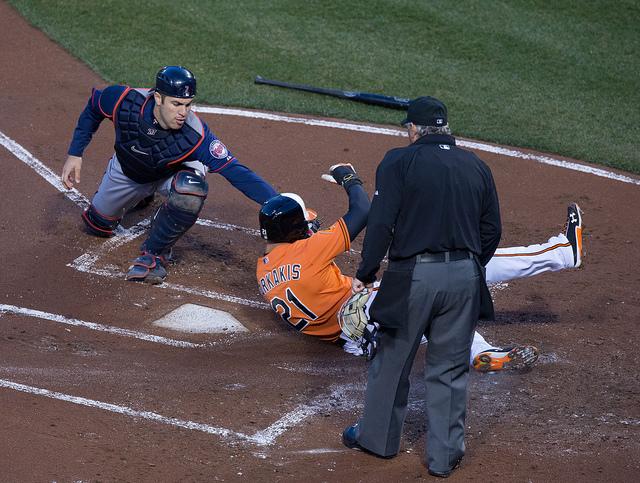What is the man doing?
Keep it brief. Sliding. What hand is the catcher tagging the runner with?
Concise answer only. Left. What no is on the man's orange t shirt?
Answer briefly. 21. What sport are they playing?
Answer briefly. Baseball. 